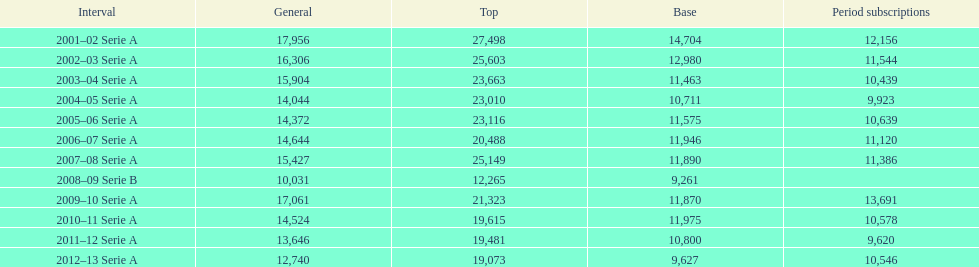What was the number of season tickets in 2007? 11,386. 